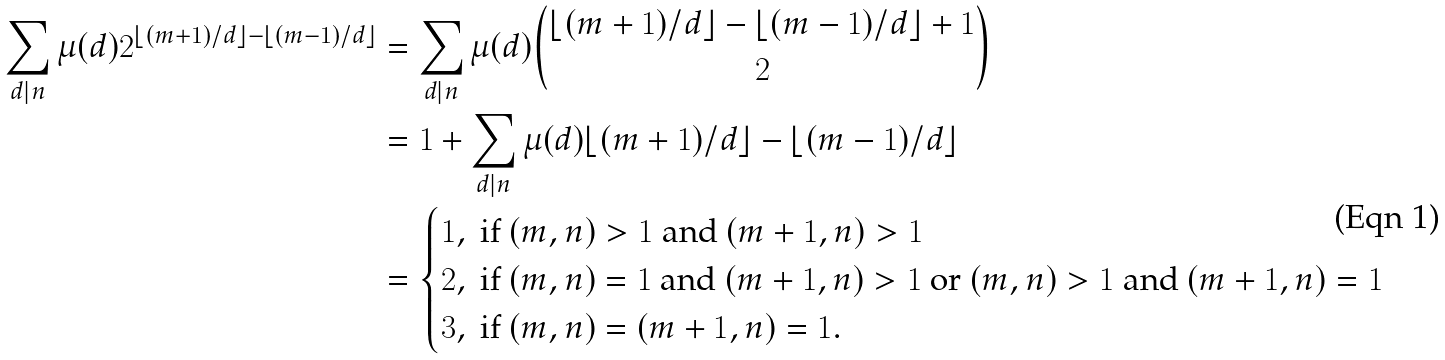Convert formula to latex. <formula><loc_0><loc_0><loc_500><loc_500>\sum _ { d | n } \mu ( d ) 2 ^ { \lfloor ( m + 1 ) / d \rfloor - \lfloor ( m - 1 ) / d \rfloor } & = \sum _ { d | n } \mu ( d ) \binom { \lfloor ( m + 1 ) / d \rfloor - \lfloor ( m - 1 ) / d \rfloor + 1 } { 2 } \\ & = 1 + \sum _ { d | n } \mu ( d ) \lfloor ( m + 1 ) / d \rfloor - \lfloor ( m - 1 ) / d \rfloor \\ & = \begin{cases} 1 , \ \text {if $(m,n)>1$ and $(m+1,n)>1$} \\ 2 , \ \text {if $(m,n)=1$ and $(m+1,n)>1$      or $(m,n)>1$ and $(m+1,n)=1$} \\ 3 , \ \text {if $(m,n)=(m+1,n)=1$} . \end{cases}</formula> 